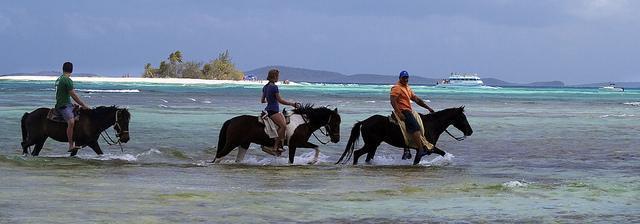How many horses are in this photo?
Give a very brief answer. 3. How many horses are visible?
Give a very brief answer. 3. How many giraffes are visible?
Give a very brief answer. 0. 